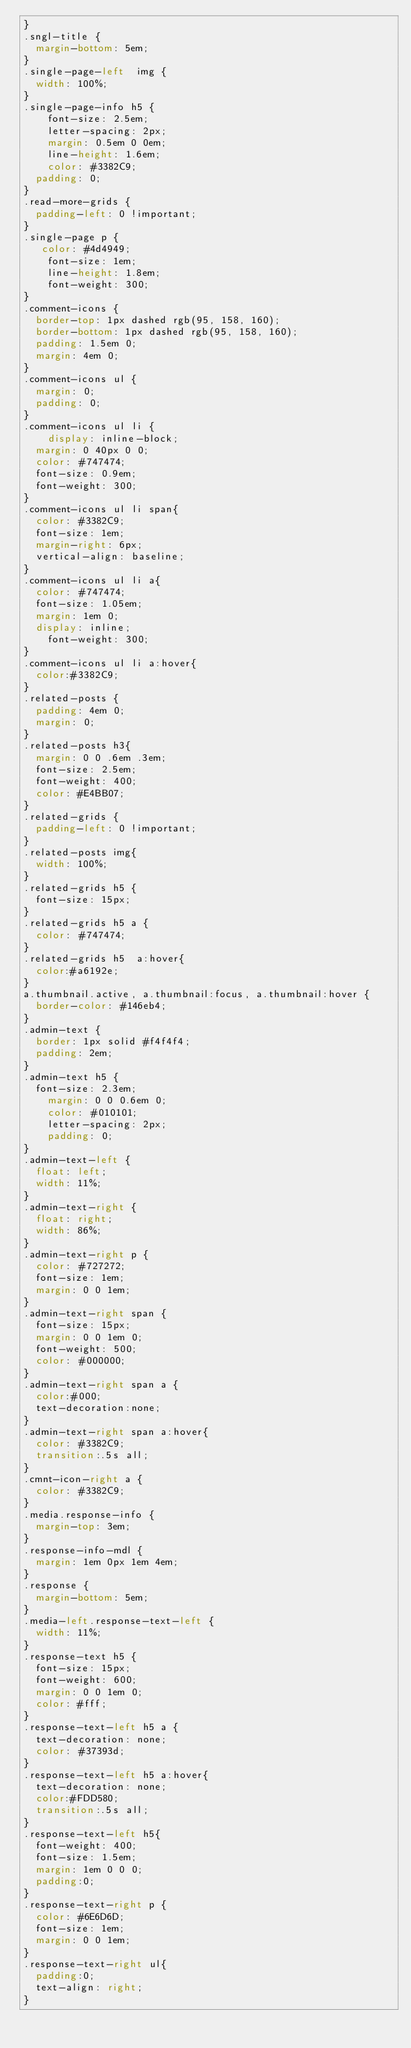<code> <loc_0><loc_0><loc_500><loc_500><_CSS_>}
.sngl-title {
  margin-bottom: 5em;
}
.single-page-left  img {
  width: 100%;
}
.single-page-info h5 {
    font-size: 2.5em;
    letter-spacing: 2px;
    margin: 0.5em 0 0em;
    line-height: 1.6em;
    color: #3382C9;
	padding: 0;
}
.read-more-grids {
  padding-left: 0 !important;
}
.single-page p {
   color: #4d4949;
    font-size: 1em;
    line-height: 1.8em;
    font-weight: 300;
}
.comment-icons {
	border-top: 1px dashed rgb(95, 158, 160);
	border-bottom: 1px dashed rgb(95, 158, 160);
	padding: 1.5em 0;
	margin: 4em 0;
}
.comment-icons ul {
	margin: 0;
	padding: 0;
}
.comment-icons ul li {
	  display: inline-block;
  margin: 0 40px 0 0;
  color: #747474;
  font-size: 0.9em;
  font-weight: 300;
}
.comment-icons ul li span{
  color: #3382C9;
  font-size: 1em;
  margin-right: 6px;
  vertical-align: baseline;
}
.comment-icons ul li a{
  color: #747474;
  font-size: 1.05em;
  margin: 1em 0;
  display: inline;
    font-weight: 300;
}
.comment-icons ul li a:hover{
	color:#3382C9;
}
.related-posts {
  padding: 4em 0;
  margin: 0;
}
.related-posts h3{
	margin: 0 0 .6em .3em;
	font-size: 2.5em;
	font-weight: 400;
	color: #E4BB07;
}
.related-grids {
  padding-left: 0 !important;
}
.related-posts img{
	width: 100%;
}
.related-grids h5 {
  font-size: 15px;
}
.related-grids h5 a {
  color: #747474;
}
.related-grids h5  a:hover{
  color:#a6192e;
}
a.thumbnail.active, a.thumbnail:focus, a.thumbnail:hover {
  border-color: #146eb4;
}
.admin-text {
	border: 1px solid #f4f4f4;
	padding: 2em;
}
.admin-text h5 {
	font-size: 2.3em;
    margin: 0 0 0.6em 0;
    color: #010101;
    letter-spacing: 2px;
    padding: 0;
}
.admin-text-left {
	float: left;
	width: 11%;
}
.admin-text-right {
	float: right;
	width: 86%;
}
.admin-text-right p {
  color: #727272;
  font-size: 1em;
  margin: 0 0 1em;
}
.admin-text-right span {
  font-size: 15px;
  margin: 0 0 1em 0;
  font-weight: 500;
  color: #000000;
}
.admin-text-right span a {
	color:#000;
	text-decoration:none;
}
.admin-text-right span a:hover{
	color: #3382C9;
	transition:.5s all;
}
.cmnt-icon-right a {
	color: #3382C9;
}
.media.response-info {
  margin-top: 3em;
}
.response-info-mdl {
  margin: 1em 0px 1em 4em;
}
.response {
  margin-bottom: 5em;
}
.media-left.response-text-left {
  width: 11%;
}
.response-text h5 {
	font-size: 15px;
	font-weight: 600;
	margin: 0 0 1em 0;
	color: #fff;
}
.response-text-left h5 a {
	text-decoration: none;
	color: #37393d;
}
.response-text-left h5 a:hover{
	text-decoration: none;
	color:#FDD580;
	transition:.5s all;
}
.response-text-left h5{
  font-weight: 400;
  font-size: 1.5em;
  margin: 1em 0 0 0;
  padding:0;
}
.response-text-right p {
  color: #6E6D6D;
  font-size: 1em;
  margin: 0 0 1em;
}
.response-text-right ul{
	padding:0;	
	text-align: right;
}</code> 